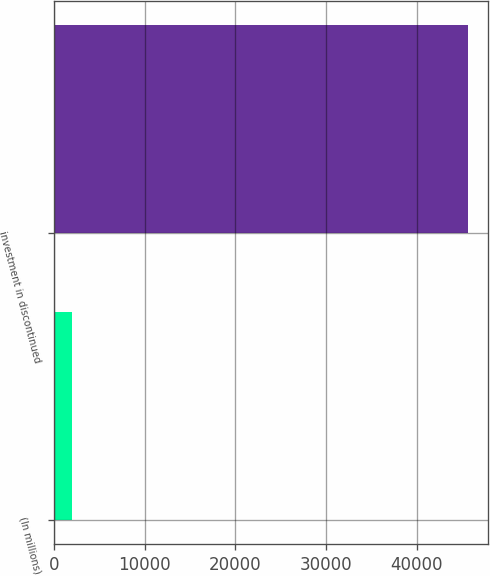<chart> <loc_0><loc_0><loc_500><loc_500><bar_chart><fcel>(In millions)<fcel>investment in discontinued<nl><fcel>2014<fcel>45589<nl></chart> 